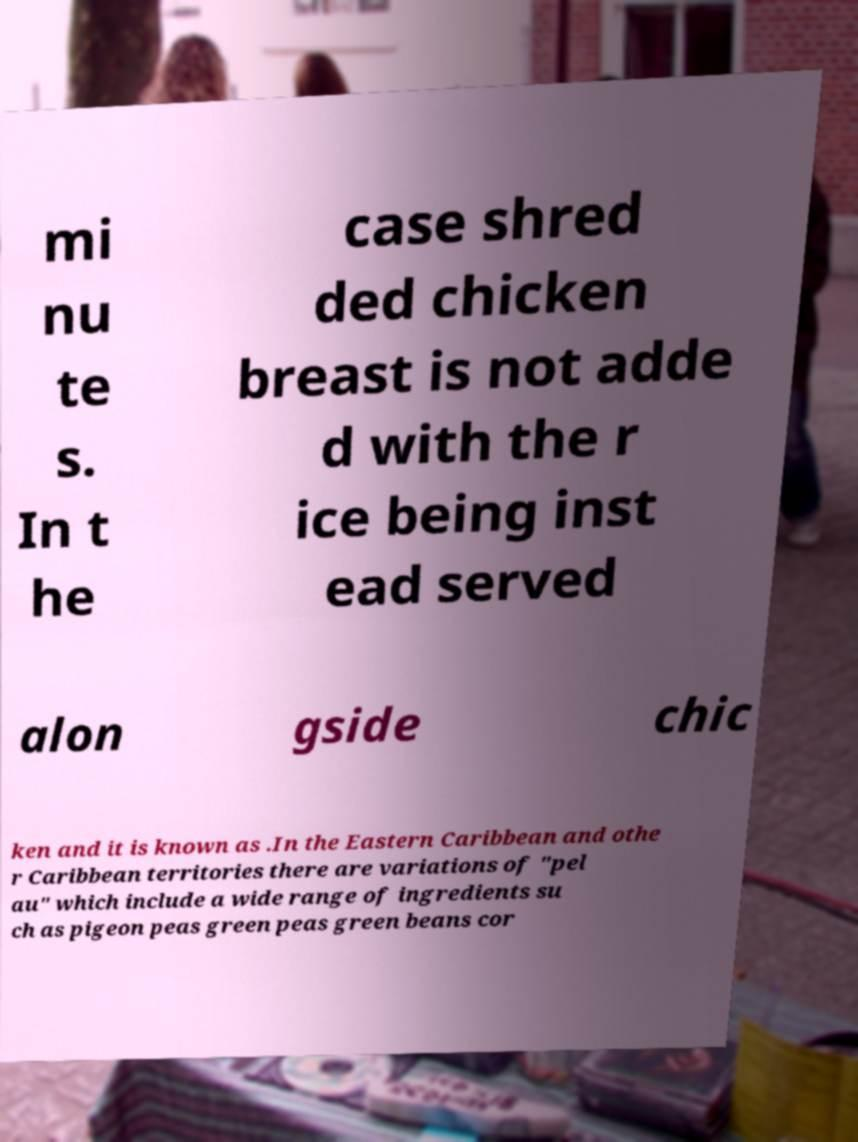I need the written content from this picture converted into text. Can you do that? mi nu te s. In t he case shred ded chicken breast is not adde d with the r ice being inst ead served alon gside chic ken and it is known as .In the Eastern Caribbean and othe r Caribbean territories there are variations of "pel au" which include a wide range of ingredients su ch as pigeon peas green peas green beans cor 